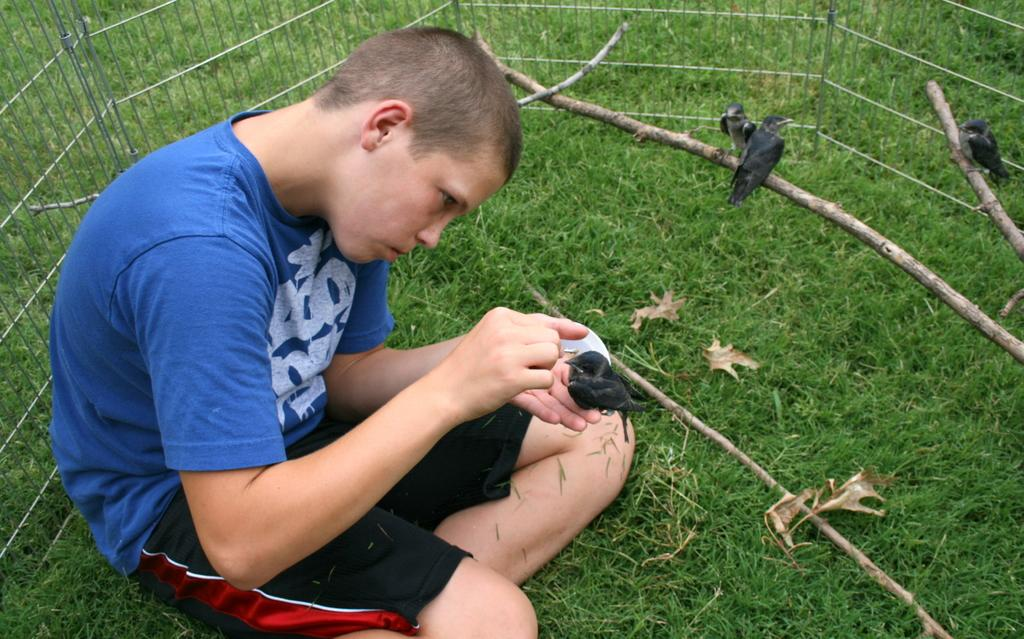Who is the main subject in the image? There is a boy in the center of the image. What is the boy holding in the image? The boy is holding a bird. What can be seen at the top of the image? There are birds standing on sticks at the top of the image. What is visible in the background of the image? There is a grill and grass in the background of the image. Is the boy's grandmother present in the image? There is no mention of a grandmother in the image, so we cannot confirm her presence. 